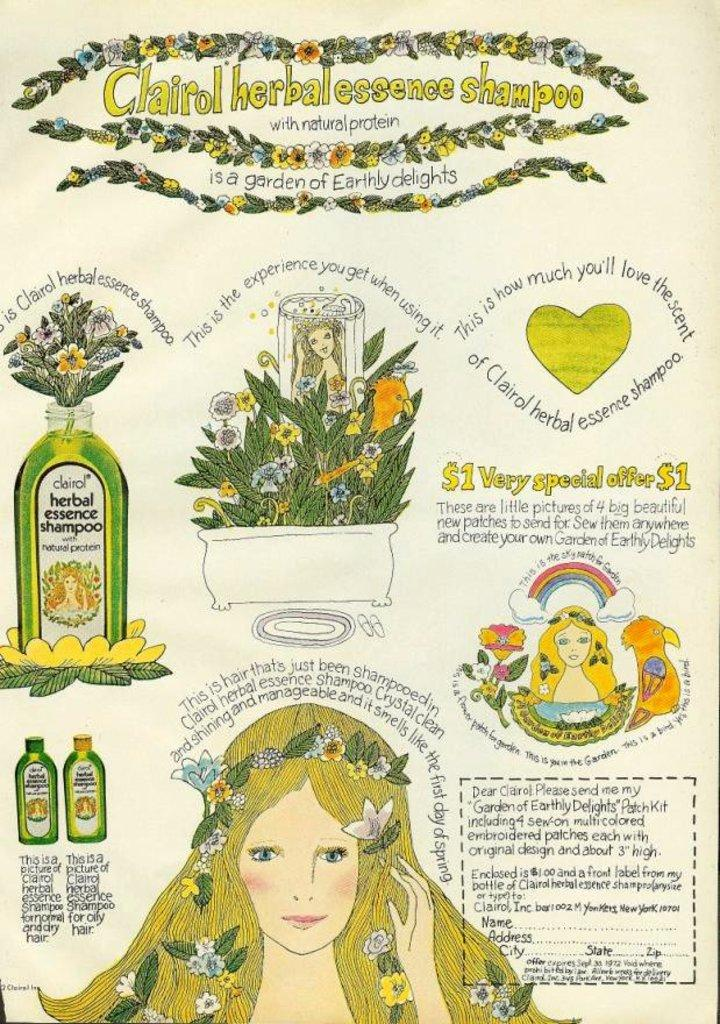What is the main subject of the poster in the image? The poster contains images of women, bottles, plants, and flowers. What type of objects are depicted alongside the women in the poster? The poster contains images of bottles, plants, and flowers alongside the women. What additional information is present on the poster? The poster contains some information. How many cakes are displayed on the poster? There are no cakes present on the poster; it contains images of women, bottles, plants, and flowers. What type of nail is used to hang the poster? The poster is not shown being hung in the image, so it is impossible to determine the type of nail used. 